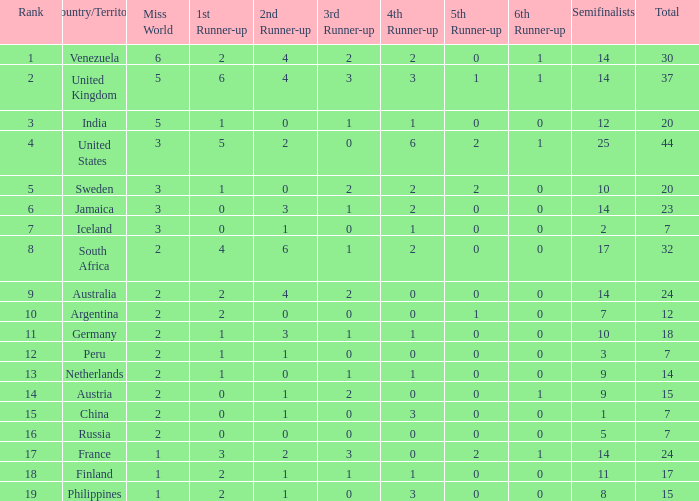Can you parse all the data within this table? {'header': ['Rank', 'Country/Territory', 'Miss World', '1st Runner-up', '2nd Runner-up', '3rd Runner-up', '4th Runner-up', '5th Runner-up', '6th Runner-up', 'Semifinalists', 'Total'], 'rows': [['1', 'Venezuela', '6', '2', '4', '2', '2', '0', '1', '14', '30'], ['2', 'United Kingdom', '5', '6', '4', '3', '3', '1', '1', '14', '37'], ['3', 'India', '5', '1', '0', '1', '1', '0', '0', '12', '20'], ['4', 'United States', '3', '5', '2', '0', '6', '2', '1', '25', '44'], ['5', 'Sweden', '3', '1', '0', '2', '2', '2', '0', '10', '20'], ['6', 'Jamaica', '3', '0', '3', '1', '2', '0', '0', '14', '23'], ['7', 'Iceland', '3', '0', '1', '0', '1', '0', '0', '2', '7'], ['8', 'South Africa', '2', '4', '6', '1', '2', '0', '0', '17', '32'], ['9', 'Australia', '2', '2', '4', '2', '0', '0', '0', '14', '24'], ['10', 'Argentina', '2', '2', '0', '0', '0', '1', '0', '7', '12'], ['11', 'Germany', '2', '1', '3', '1', '1', '0', '0', '10', '18'], ['12', 'Peru', '2', '1', '1', '0', '0', '0', '0', '3', '7'], ['13', 'Netherlands', '2', '1', '0', '1', '1', '0', '0', '9', '14'], ['14', 'Austria', '2', '0', '1', '2', '0', '0', '1', '9', '15'], ['15', 'China', '2', '0', '1', '0', '3', '0', '0', '1', '7'], ['16', 'Russia', '2', '0', '0', '0', '0', '0', '0', '5', '7'], ['17', 'France', '1', '3', '2', '3', '0', '2', '1', '14', '24'], ['18', 'Finland', '1', '2', '1', '1', '1', '0', '0', '11', '17'], ['19', 'Philippines', '1', '2', '1', '0', '3', '0', '0', '8', '15']]} Which countries have a 5th runner-up ranking is 2 and the 3rd runner-up ranking is 0 44.0. 